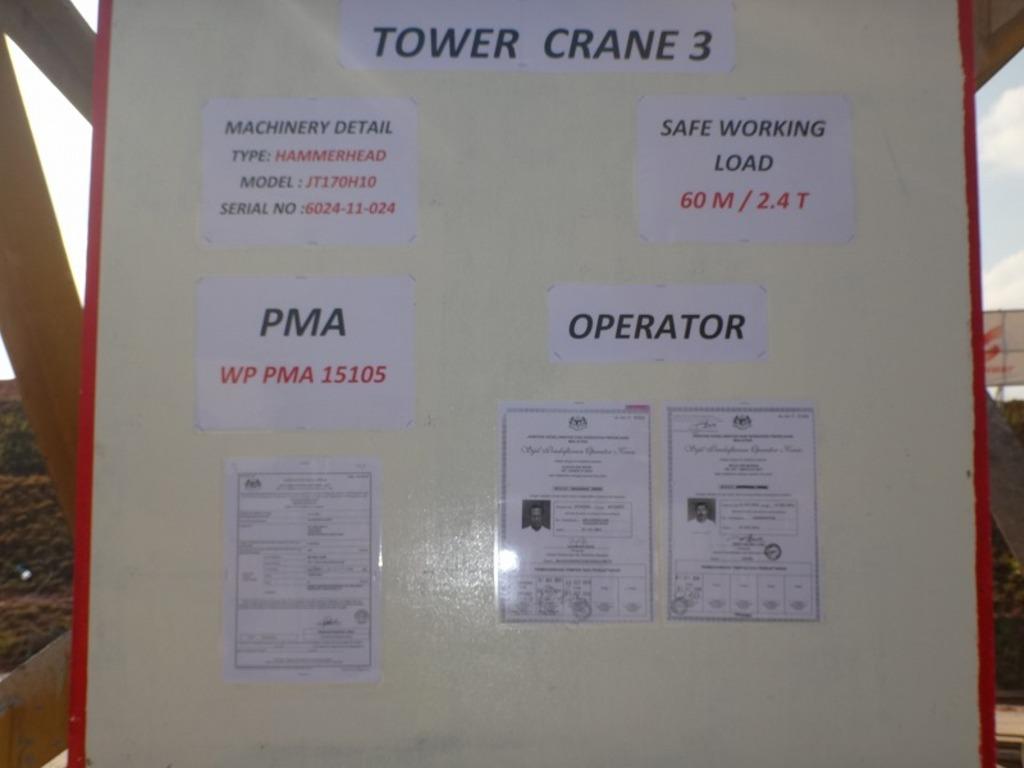Where is the operator section?
Your answer should be compact. Tower crane 3. What is the pma number?
Your answer should be very brief. 15105. 